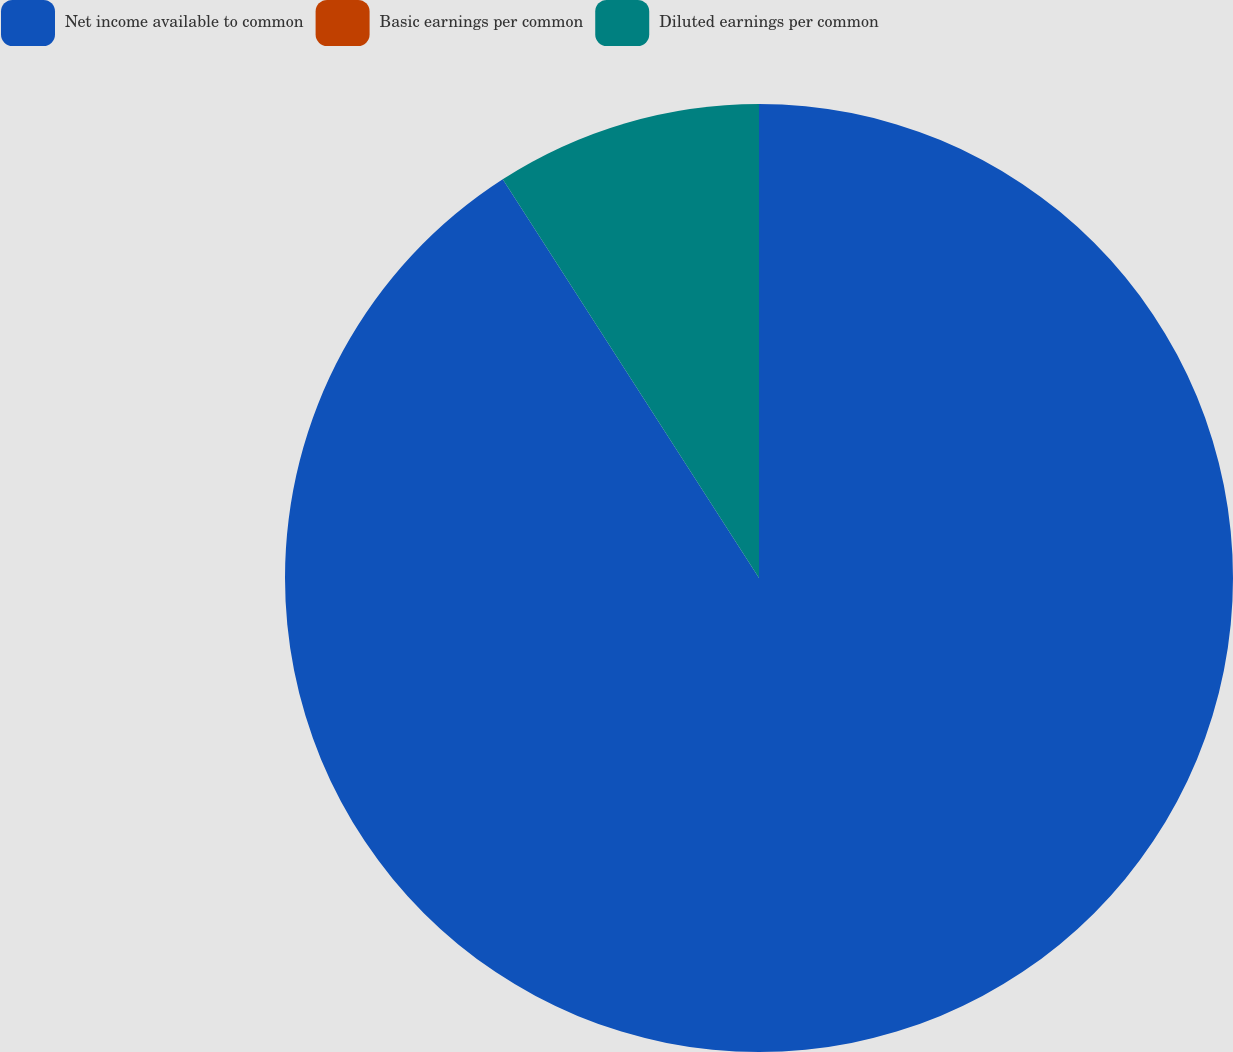Convert chart. <chart><loc_0><loc_0><loc_500><loc_500><pie_chart><fcel>Net income available to common<fcel>Basic earnings per common<fcel>Diluted earnings per common<nl><fcel>90.9%<fcel>0.0%<fcel>9.09%<nl></chart> 